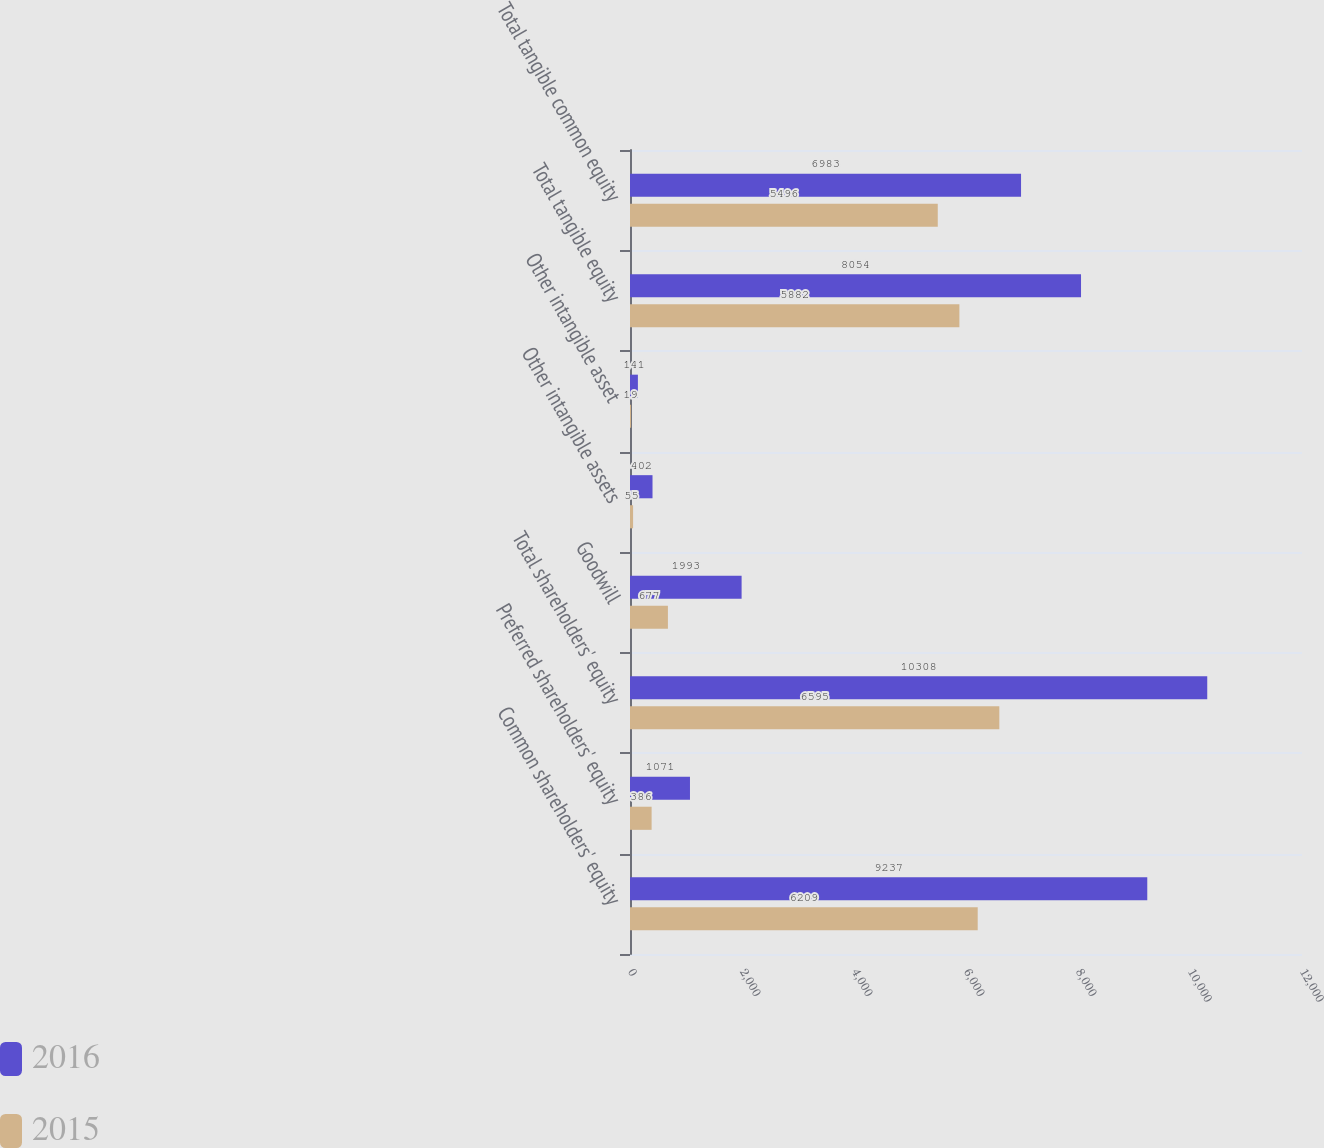Convert chart. <chart><loc_0><loc_0><loc_500><loc_500><stacked_bar_chart><ecel><fcel>Common shareholders' equity<fcel>Preferred shareholders' equity<fcel>Total shareholders' equity<fcel>Goodwill<fcel>Other intangible assets<fcel>Other intangible asset<fcel>Total tangible equity<fcel>Total tangible common equity<nl><fcel>2016<fcel>9237<fcel>1071<fcel>10308<fcel>1993<fcel>402<fcel>141<fcel>8054<fcel>6983<nl><fcel>2015<fcel>6209<fcel>386<fcel>6595<fcel>677<fcel>55<fcel>19<fcel>5882<fcel>5496<nl></chart> 